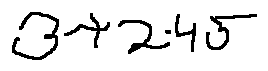Convert formula to latex. <formula><loc_0><loc_0><loc_500><loc_500>3 + 2 \cdot 4 5</formula> 